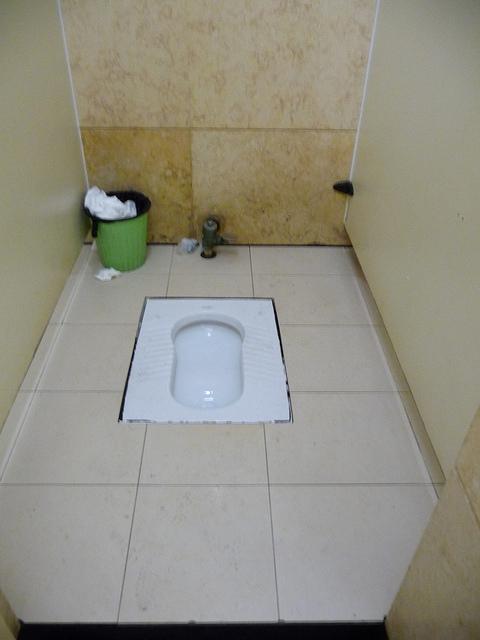How many teddy bears are in the scene?
Give a very brief answer. 0. 